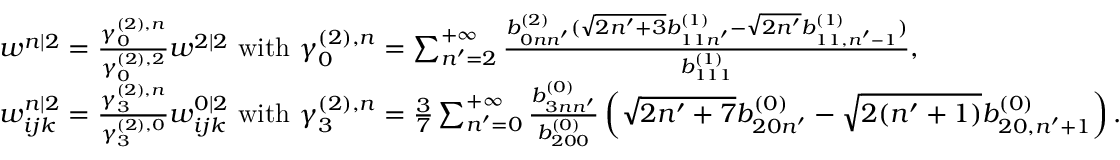<formula> <loc_0><loc_0><loc_500><loc_500>\begin{array} { r l } & { w ^ { n | 2 } = \frac { \gamma _ { 0 } ^ { ( 2 ) , n } } { \gamma _ { 0 } ^ { ( 2 ) , 2 } } w ^ { 2 | 2 } w i t h \gamma _ { 0 } ^ { ( 2 ) , n } = \sum _ { n ^ { \prime } = 2 } ^ { + \infty } \frac { b _ { 0 n n ^ { \prime } } ^ { ( 2 ) } ( \sqrt { 2 n ^ { \prime } + 3 } b _ { 1 1 n ^ { \prime } } ^ { ( 1 ) } - \sqrt { 2 n ^ { \prime } } b _ { 1 1 , n ^ { \prime } - 1 } ^ { ( 1 ) } ) } { b _ { 1 1 1 } ^ { ( 1 ) } } , } \\ & { w _ { i j k } ^ { n | 2 } = \frac { \gamma _ { 3 } ^ { ( 2 ) , n } } { \gamma _ { 3 } ^ { ( 2 ) , 0 } } w _ { i j k } ^ { 0 | 2 } w i t h \gamma _ { 3 } ^ { ( 2 ) , n } = \frac { 3 } { 7 } \sum _ { n ^ { \prime } = 0 } ^ { + \infty } \frac { b _ { 3 n n ^ { \prime } } ^ { ( 0 ) } } { b _ { 2 0 0 } ^ { ( 0 ) } } \left ( \sqrt { 2 n ^ { \prime } + 7 } b _ { 2 0 n ^ { \prime } } ^ { ( 0 ) } - \sqrt { 2 ( n ^ { \prime } + 1 ) } b _ { 2 0 , n ^ { \prime } + 1 } ^ { ( 0 ) } \right ) . } \end{array}</formula> 